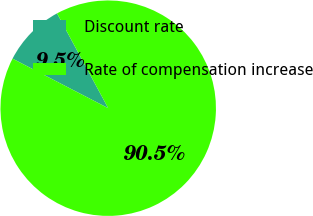Convert chart to OTSL. <chart><loc_0><loc_0><loc_500><loc_500><pie_chart><fcel>Discount rate<fcel>Rate of compensation increase<nl><fcel>9.52%<fcel>90.48%<nl></chart> 